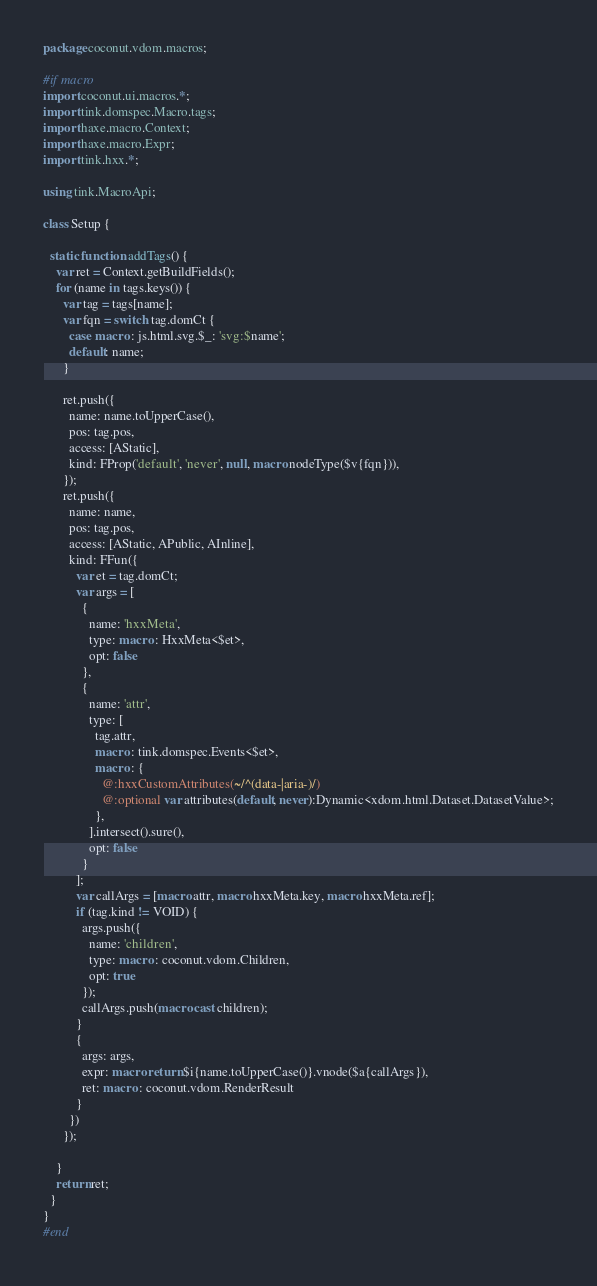<code> <loc_0><loc_0><loc_500><loc_500><_Haxe_>package coconut.vdom.macros;

#if macro
import coconut.ui.macros.*;
import tink.domspec.Macro.tags;
import haxe.macro.Context;
import haxe.macro.Expr;
import tink.hxx.*;

using tink.MacroApi;

class Setup {

  static function addTags() {
    var ret = Context.getBuildFields();
    for (name in tags.keys()) {
      var tag = tags[name];
      var fqn = switch tag.domCt {
        case macro : js.html.svg.$_: 'svg:$name';
        default: name;
      }

      ret.push({
        name: name.toUpperCase(),
        pos: tag.pos,
        access: [AStatic],
        kind: FProp('default', 'never', null, macro nodeType($v{fqn})),
      });
      ret.push({
        name: name,
        pos: tag.pos,
        access: [AStatic, APublic, AInline],
        kind: FFun({
          var et = tag.domCt;
          var args = [
            {
              name: 'hxxMeta',
              type: macro : HxxMeta<$et>,
              opt: false
            },
            {
              name: 'attr',
              type: [
                tag.attr,
                macro : tink.domspec.Events<$et>,
                macro : {
                  @:hxxCustomAttributes(~/^(data-|aria-)/)
                  @:optional var attributes(default, never):Dynamic<xdom.html.Dataset.DatasetValue>;
                },
              ].intersect().sure(),
              opt: false
            }
          ];
          var callArgs = [macro attr, macro hxxMeta.key, macro hxxMeta.ref];
          if (tag.kind != VOID) {
            args.push({
              name: 'children',
              type: macro : coconut.vdom.Children,
              opt: true
            });
            callArgs.push(macro cast children);
          }
          {
            args: args,
            expr: macro return $i{name.toUpperCase()}.vnode($a{callArgs}),
            ret: macro : coconut.vdom.RenderResult
          }
        })
      });

    }
    return ret;
  }
}
#end</code> 